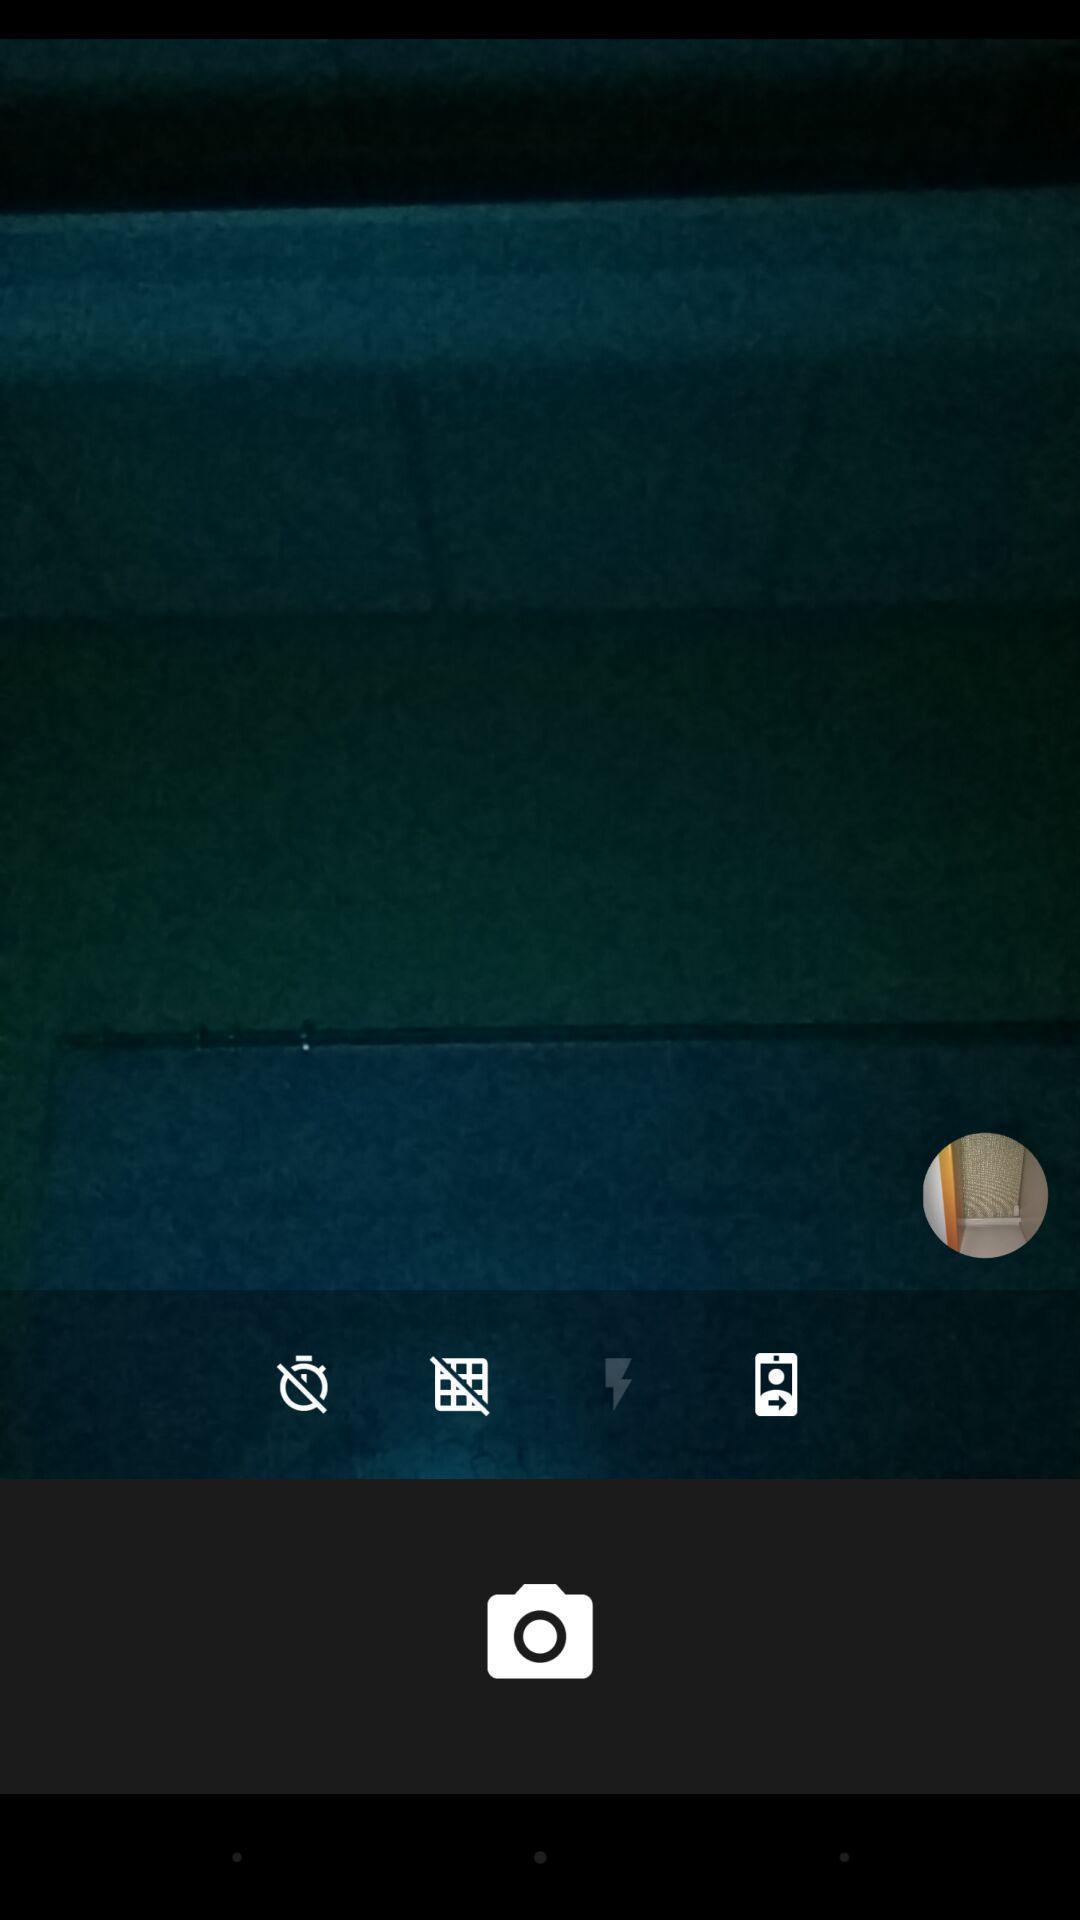Give me a narrative description of this picture. Screen shows camera icon with multiple options. 